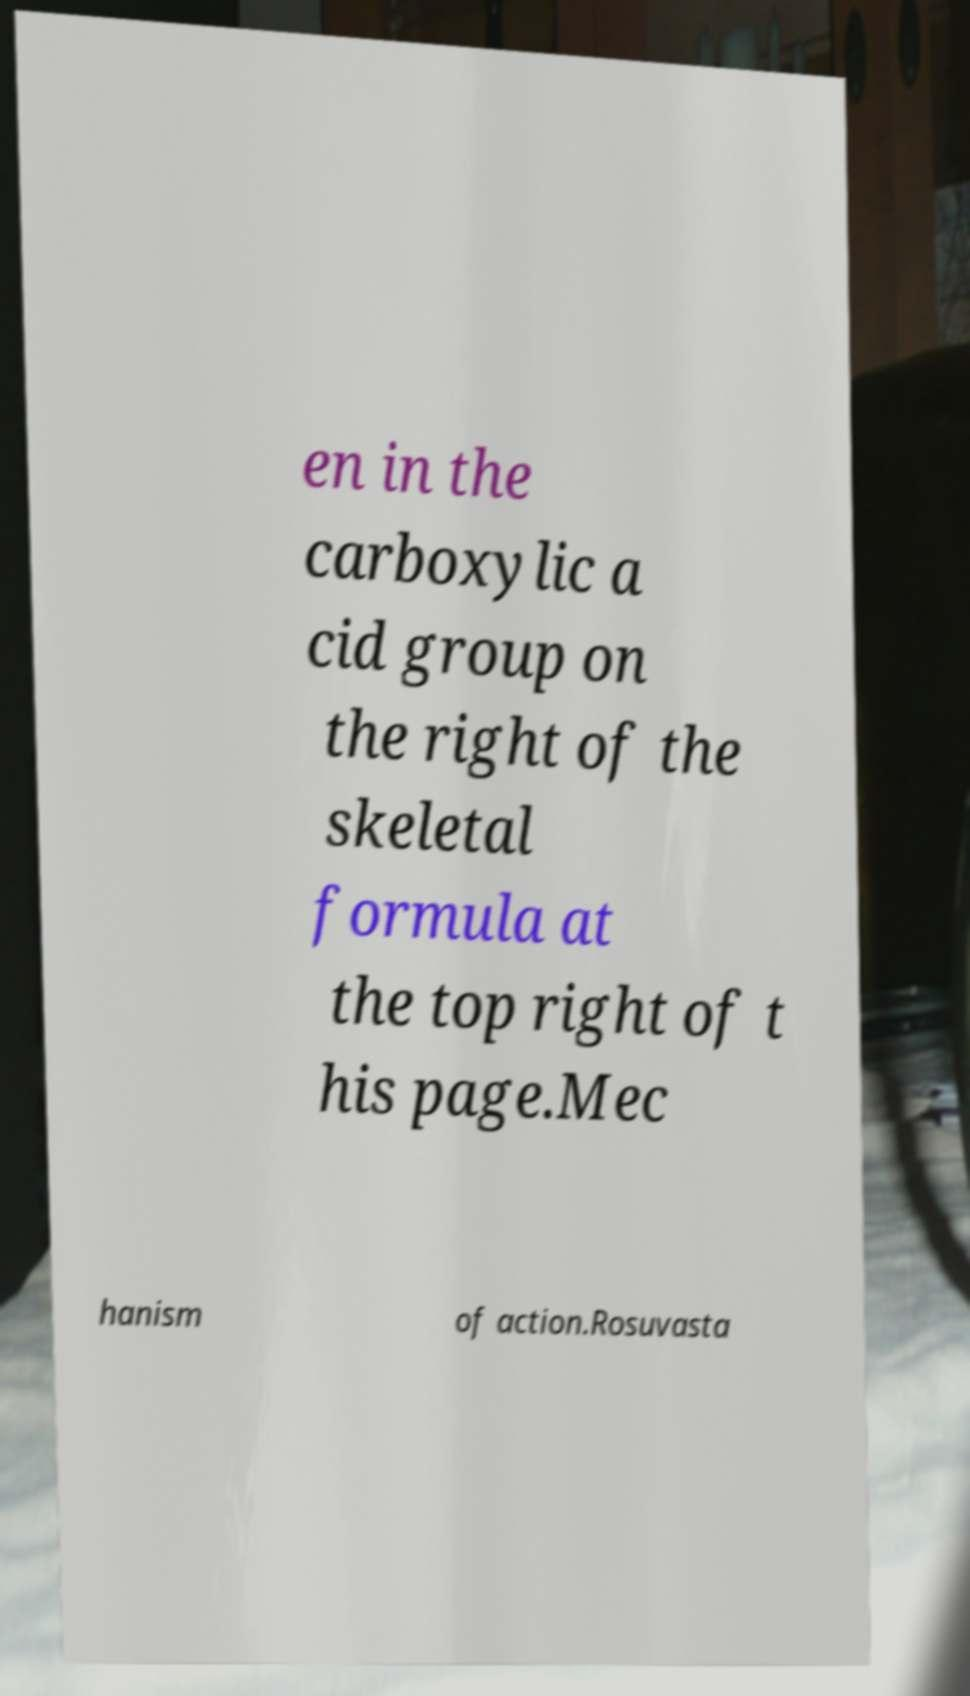Can you read and provide the text displayed in the image?This photo seems to have some interesting text. Can you extract and type it out for me? en in the carboxylic a cid group on the right of the skeletal formula at the top right of t his page.Mec hanism of action.Rosuvasta 